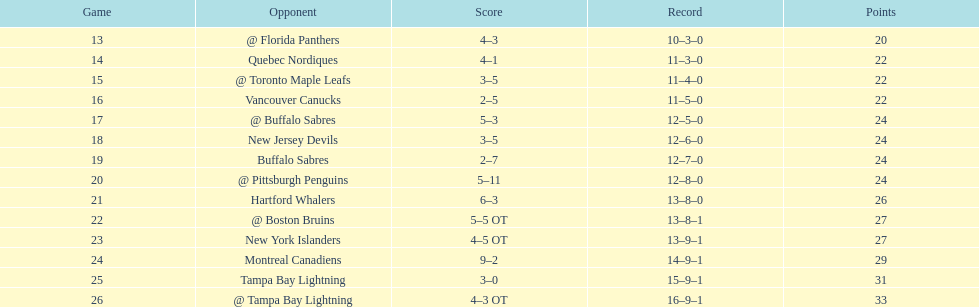Which was the only team in the atlantic division in the 1993-1994 season to acquire less points than the philadelphia flyers? Tampa Bay Lightning. 